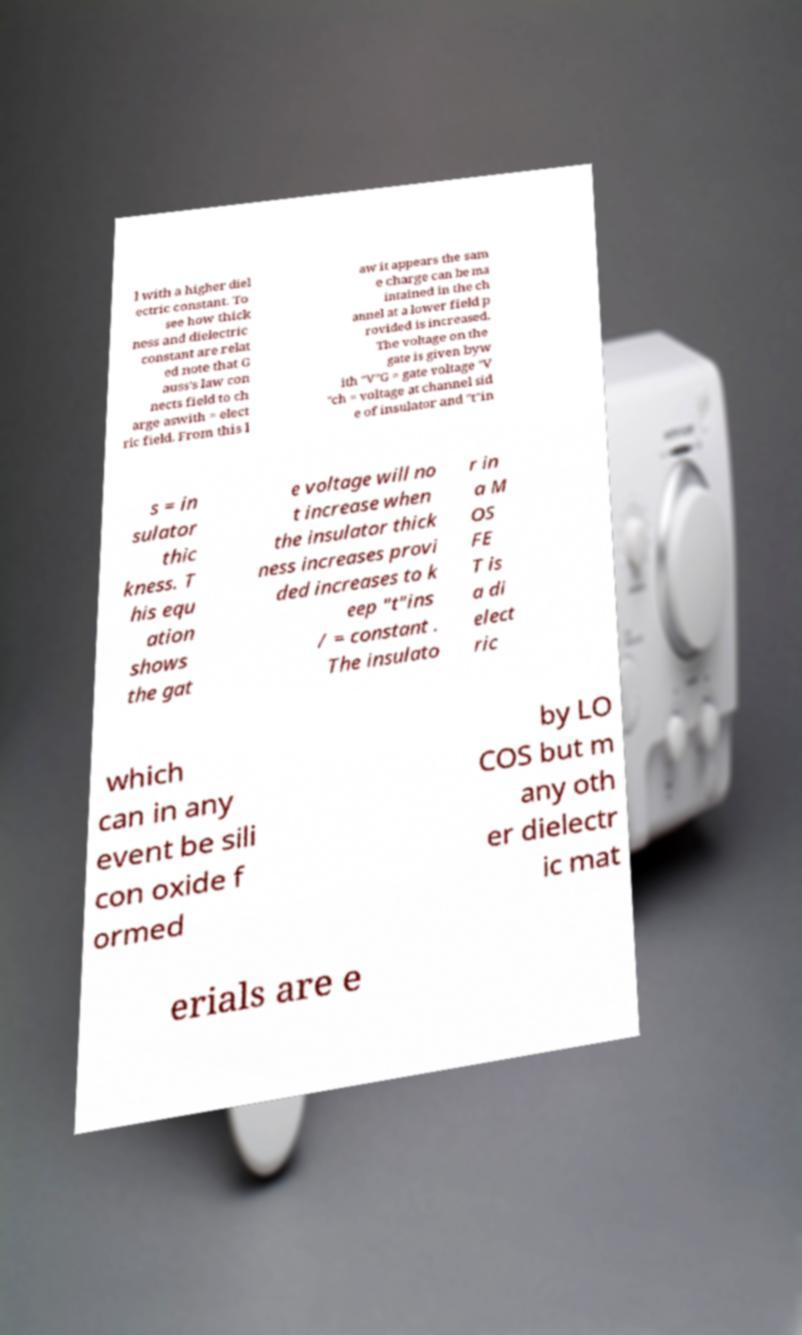For documentation purposes, I need the text within this image transcribed. Could you provide that? l with a higher diel ectric constant. To see how thick ness and dielectric constant are relat ed note that G auss's law con nects field to ch arge aswith = elect ric field. From this l aw it appears the sam e charge can be ma intained in the ch annel at a lower field p rovided is increased. The voltage on the gate is given byw ith "V"G = gate voltage "V "ch = voltage at channel sid e of insulator and "t"in s = in sulator thic kness. T his equ ation shows the gat e voltage will no t increase when the insulator thick ness increases provi ded increases to k eep "t"ins / = constant . The insulato r in a M OS FE T is a di elect ric which can in any event be sili con oxide f ormed by LO COS but m any oth er dielectr ic mat erials are e 